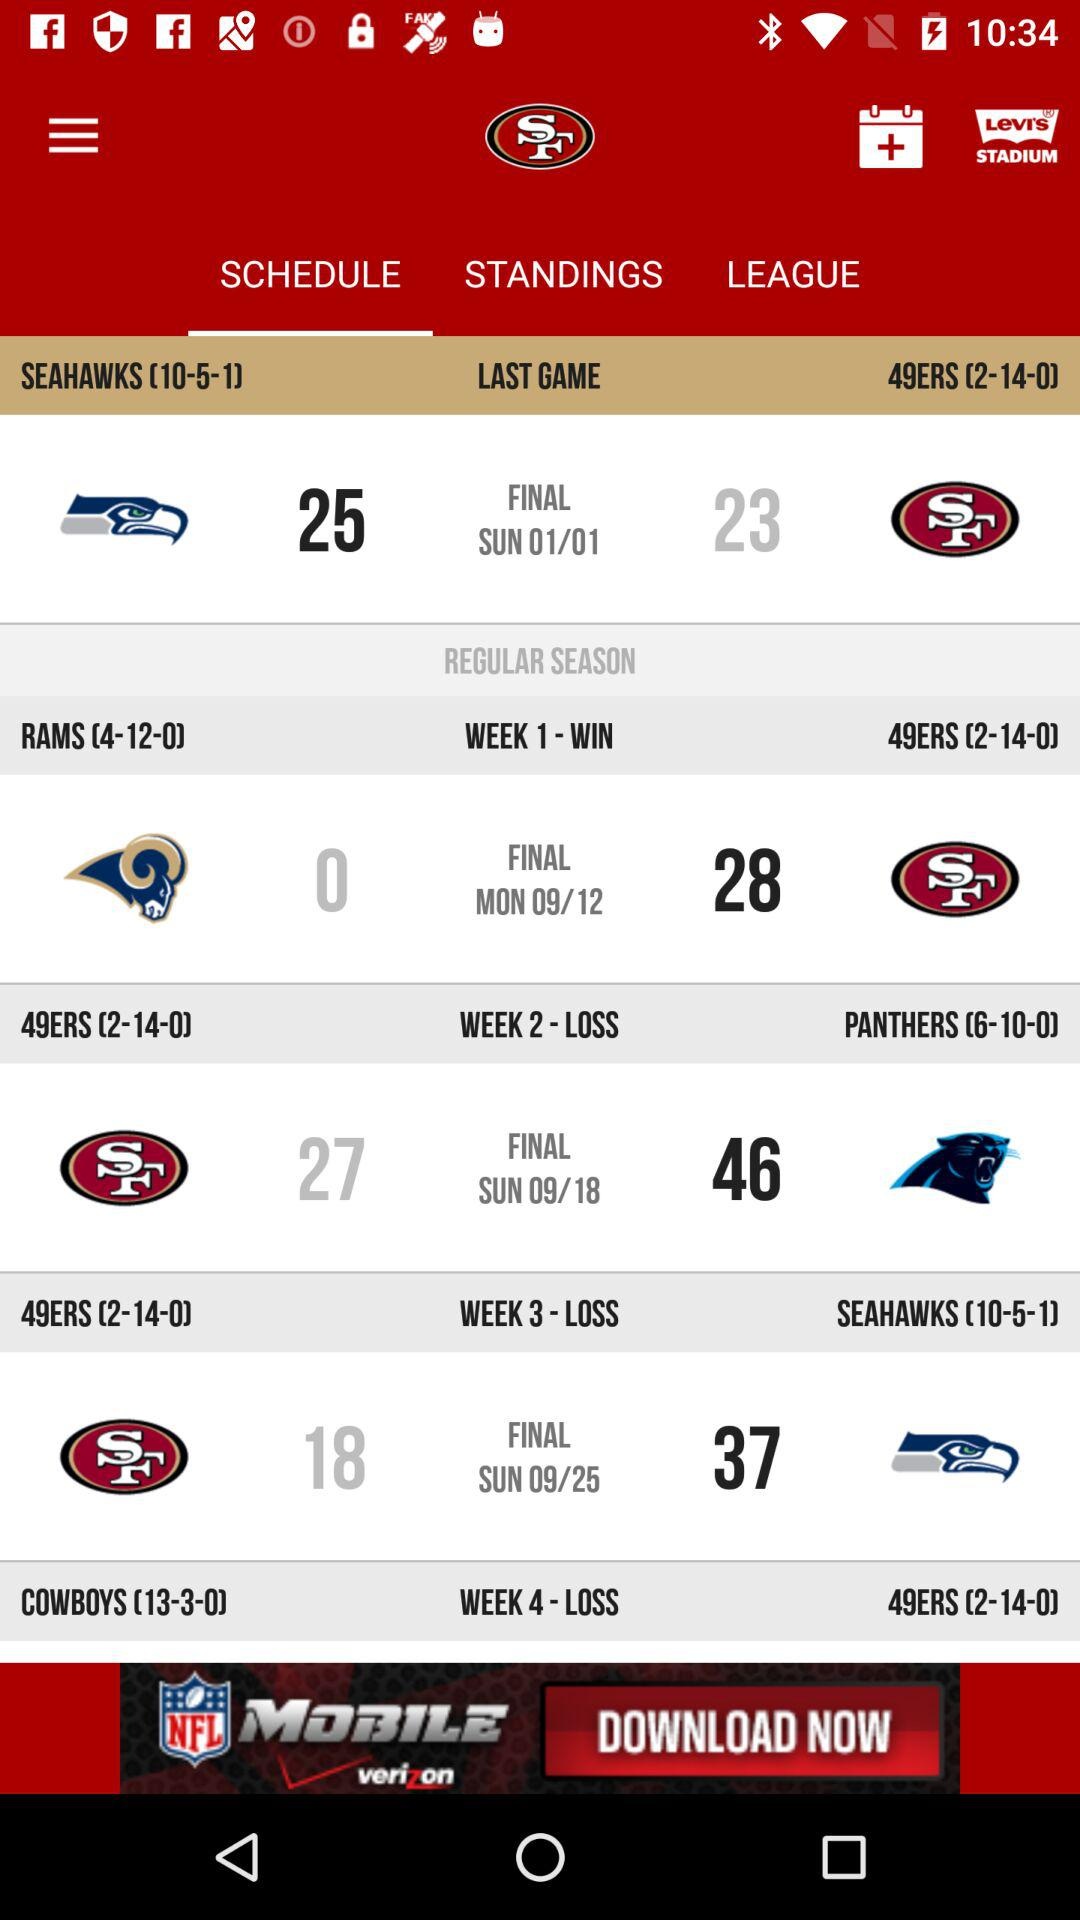What is the date on Monday? The date on Monday is September 12. 